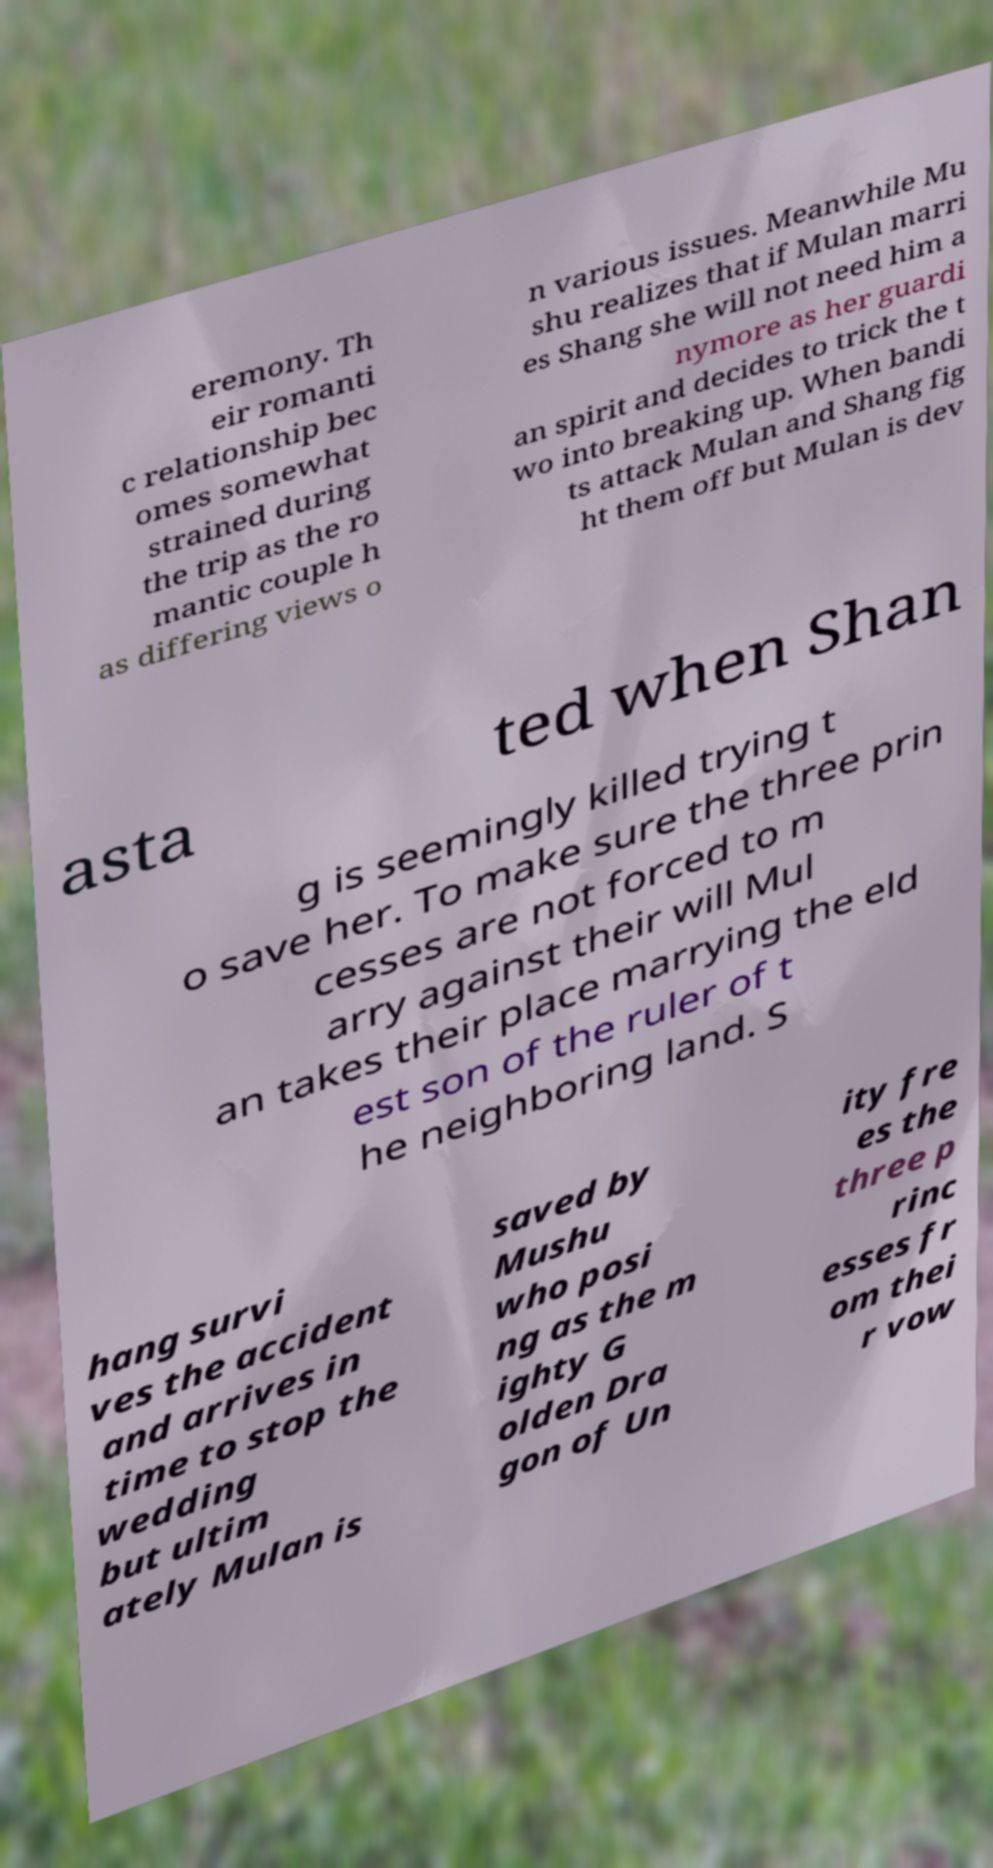Could you assist in decoding the text presented in this image and type it out clearly? eremony. Th eir romanti c relationship bec omes somewhat strained during the trip as the ro mantic couple h as differing views o n various issues. Meanwhile Mu shu realizes that if Mulan marri es Shang she will not need him a nymore as her guardi an spirit and decides to trick the t wo into breaking up. When bandi ts attack Mulan and Shang fig ht them off but Mulan is dev asta ted when Shan g is seemingly killed trying t o save her. To make sure the three prin cesses are not forced to m arry against their will Mul an takes their place marrying the eld est son of the ruler of t he neighboring land. S hang survi ves the accident and arrives in time to stop the wedding but ultim ately Mulan is saved by Mushu who posi ng as the m ighty G olden Dra gon of Un ity fre es the three p rinc esses fr om thei r vow 